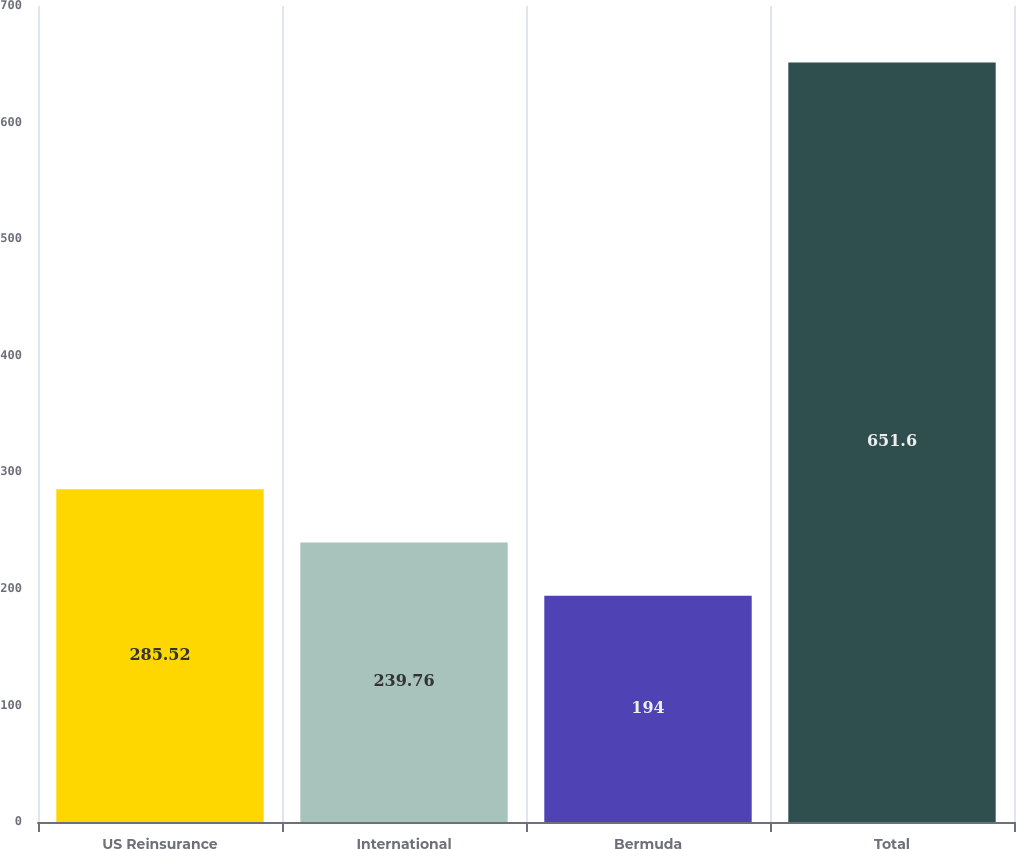Convert chart to OTSL. <chart><loc_0><loc_0><loc_500><loc_500><bar_chart><fcel>US Reinsurance<fcel>International<fcel>Bermuda<fcel>Total<nl><fcel>285.52<fcel>239.76<fcel>194<fcel>651.6<nl></chart> 